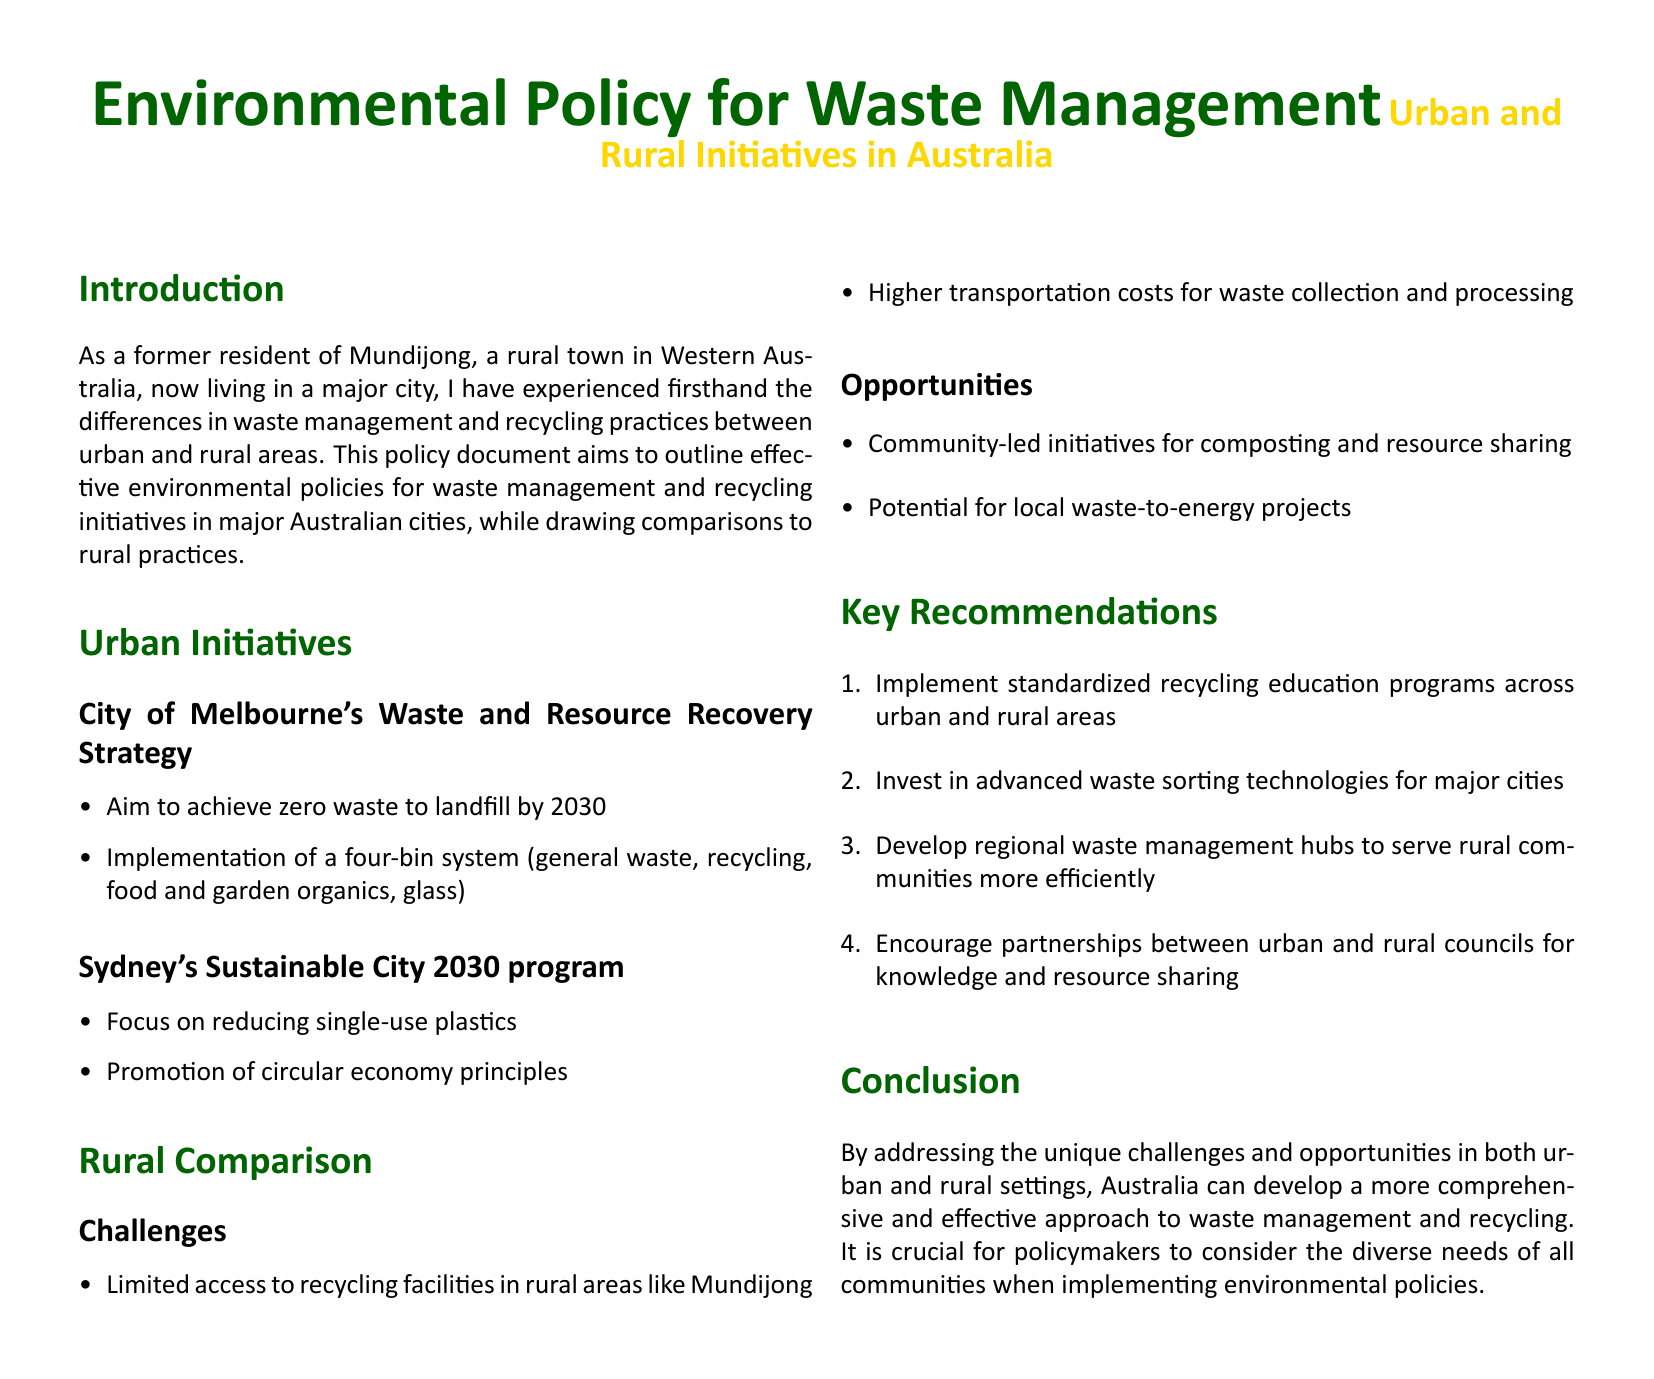what is the goal of Melbourne's Waste and Resource Recovery Strategy? The goal is to achieve zero waste to landfill by 2030.
Answer: zero waste to landfill by 2030 what type of system is implemented in Melbourne? The city has a four-bin system for waste management.
Answer: four-bin system which major city program focuses on reducing single-use plastics? The Sustainable City 2030 program of Sydney focuses on this.
Answer: Sustainable City 2030 program what is a key challenge faced by rural areas like Mundijong? Limited access to recycling facilities is a challenge in rural areas.
Answer: Limited access to recycling facilities what is one opportunity for rural waste management mentioned in the document? Community-led initiatives for composting are an opportunity.
Answer: Community-led initiatives for composting how many recommendations are provided in the document? The document provides four key recommendations.
Answer: four which principle is promoted in Sydney's Sustainable City program? Circular economy principles are promoted in the program.
Answer: circular economy principles what investment is recommended for major cities? Investing in advanced waste sorting technologies is recommended.
Answer: advanced waste sorting technologies what is a proposed solution for rural waste management efficiency? Developing regional waste management hubs is proposed.
Answer: regional waste management hubs 